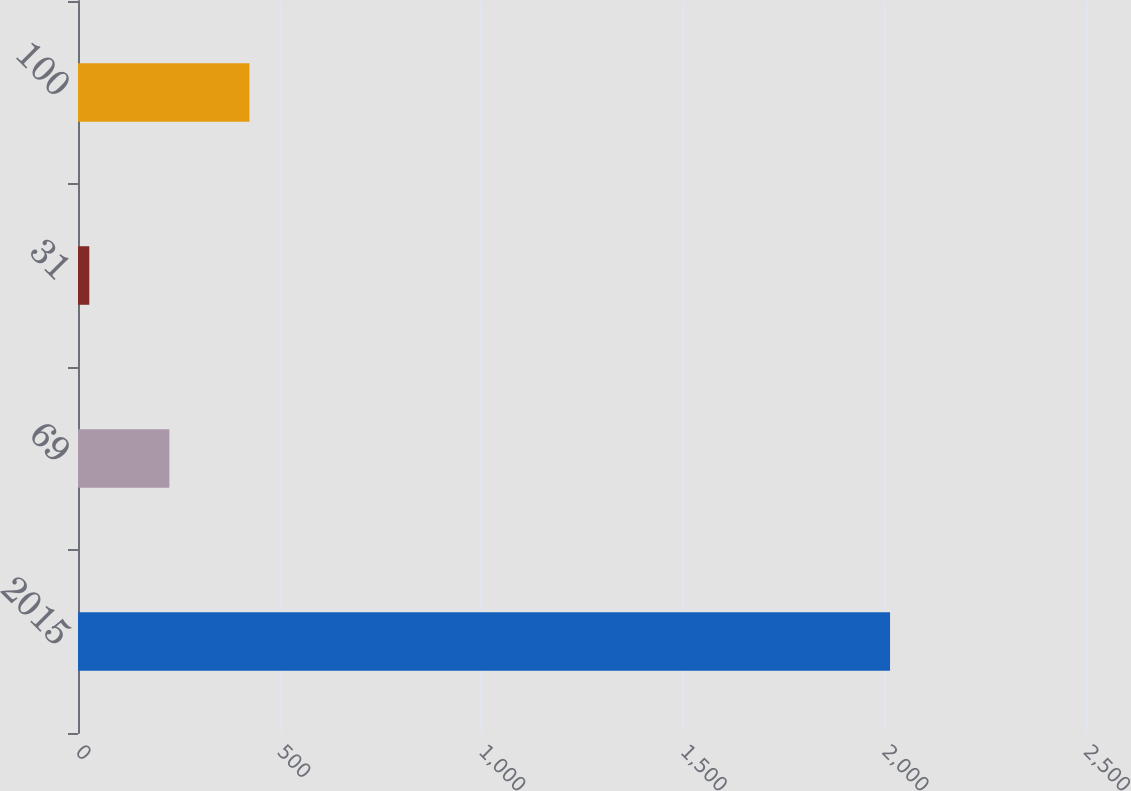Convert chart to OTSL. <chart><loc_0><loc_0><loc_500><loc_500><bar_chart><fcel>2015<fcel>69<fcel>31<fcel>100<nl><fcel>2014<fcel>226.6<fcel>28<fcel>425.2<nl></chart> 